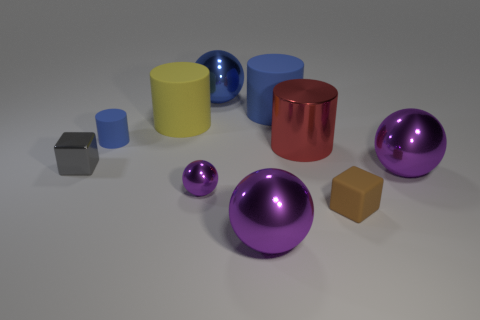How many big rubber cylinders are on the right side of the big blue shiny object and in front of the large blue matte thing?
Provide a short and direct response. 0. What is the color of the tiny block on the left side of the big matte cylinder that is to the left of the large blue cylinder?
Provide a succinct answer. Gray. Are there the same number of large rubber things that are in front of the yellow matte object and large gray blocks?
Offer a very short reply. Yes. What number of small purple shiny balls are in front of the big cylinder that is left of the metal sphere in front of the small brown matte cube?
Offer a terse response. 1. What color is the ball behind the tiny blue rubber thing?
Give a very brief answer. Blue. There is a object that is both to the left of the yellow cylinder and behind the tiny gray block; what is it made of?
Keep it short and to the point. Rubber. There is a tiny brown object that is to the right of the large yellow cylinder; what number of brown matte objects are on the right side of it?
Provide a short and direct response. 0. The blue metallic thing has what shape?
Your answer should be very brief. Sphere. The big red thing that is the same material as the tiny gray block is what shape?
Make the answer very short. Cylinder. There is a metal thing that is behind the small cylinder; does it have the same shape as the gray thing?
Make the answer very short. No. 